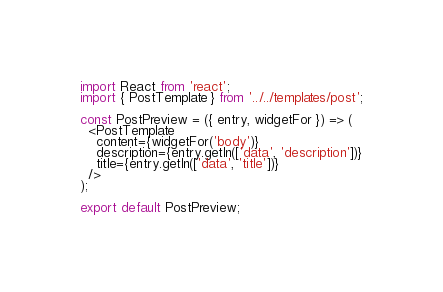Convert code to text. <code><loc_0><loc_0><loc_500><loc_500><_JavaScript_>import React from 'react';
import { PostTemplate } from '../../templates/post';

const PostPreview = ({ entry, widgetFor }) => (
  <PostTemplate
    content={widgetFor('body')}
    description={entry.getIn(['data', 'description'])}
    title={entry.getIn(['data', 'title'])}
  />
);

export default PostPreview;
</code> 